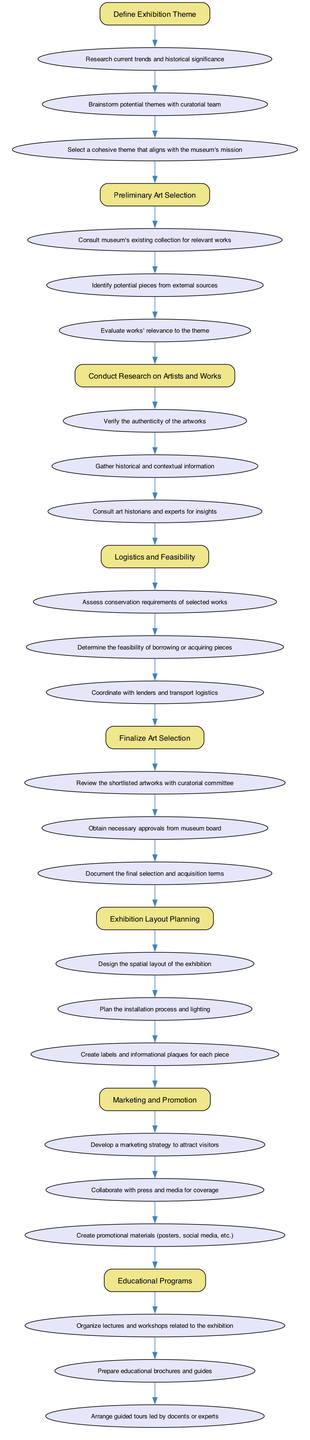What is the first step in the art selection process? The first step, as indicated in the flowchart, is "Define Exhibition Theme." It is the top-most node and serves as the starting point of the process.
Answer: Define Exhibition Theme How many actions are included in the "Logistics and Feasibility" step? The flowchart shows that there are three actions listed under the "Logistics and Feasibility" step. By counting the actions connected to this node, we confirm this total.
Answer: 3 Which step follows "Conduct Research on Artists and Works"? The step that follows "Conduct Research on Artists and Works" is "Logistics and Feasibility." This can be seen by following the arrows in the flowchart from one node to the next.
Answer: Logistics and Feasibility Name the last action in the "Marketing and Promotion" step. The last action listed in the "Marketing and Promotion" step is "Create promotional materials (posters, social media, etc.)." This can be confirmed by looking at the actions associated with this particular step.
Answer: Create promotional materials (posters, social media, etc.) What is the relationship between "Preliminary Art Selection" and "Finalize Art Selection"? The relationship is that "Finalize Art Selection" is the step that comes after "Preliminary Art Selection." In the flowchart, an arrow connects the last action of "Preliminary Art Selection" to the "Finalize Art Selection" node, indicating a progression in the process.
Answer: Finalize Art Selection How many steps are there in total in the flowchart? By counting the primary nodes in the flowchart, we find there are eight steps in total that are listed in the process. This count includes each step from "Define Exhibition Theme" to "Educational Programs."
Answer: 8 Which action comes directly after "Review the shortlisted artworks with curatorial committee"? The action that comes directly after "Review the shortlisted artworks with curatorial committee" is "Obtain necessary approvals from museum board." This is determined by examining the actions in the context of the "Finalize Art Selection" step.
Answer: Obtain necessary approvals from museum board What is the primary function of the "Educational Programs" step? The primary function of the "Educational Programs" step is to organize events such as lectures and workshops related to the exhibition. This is evident from the first action listed under this step.
Answer: Organize lectures and workshops related to the exhibition 